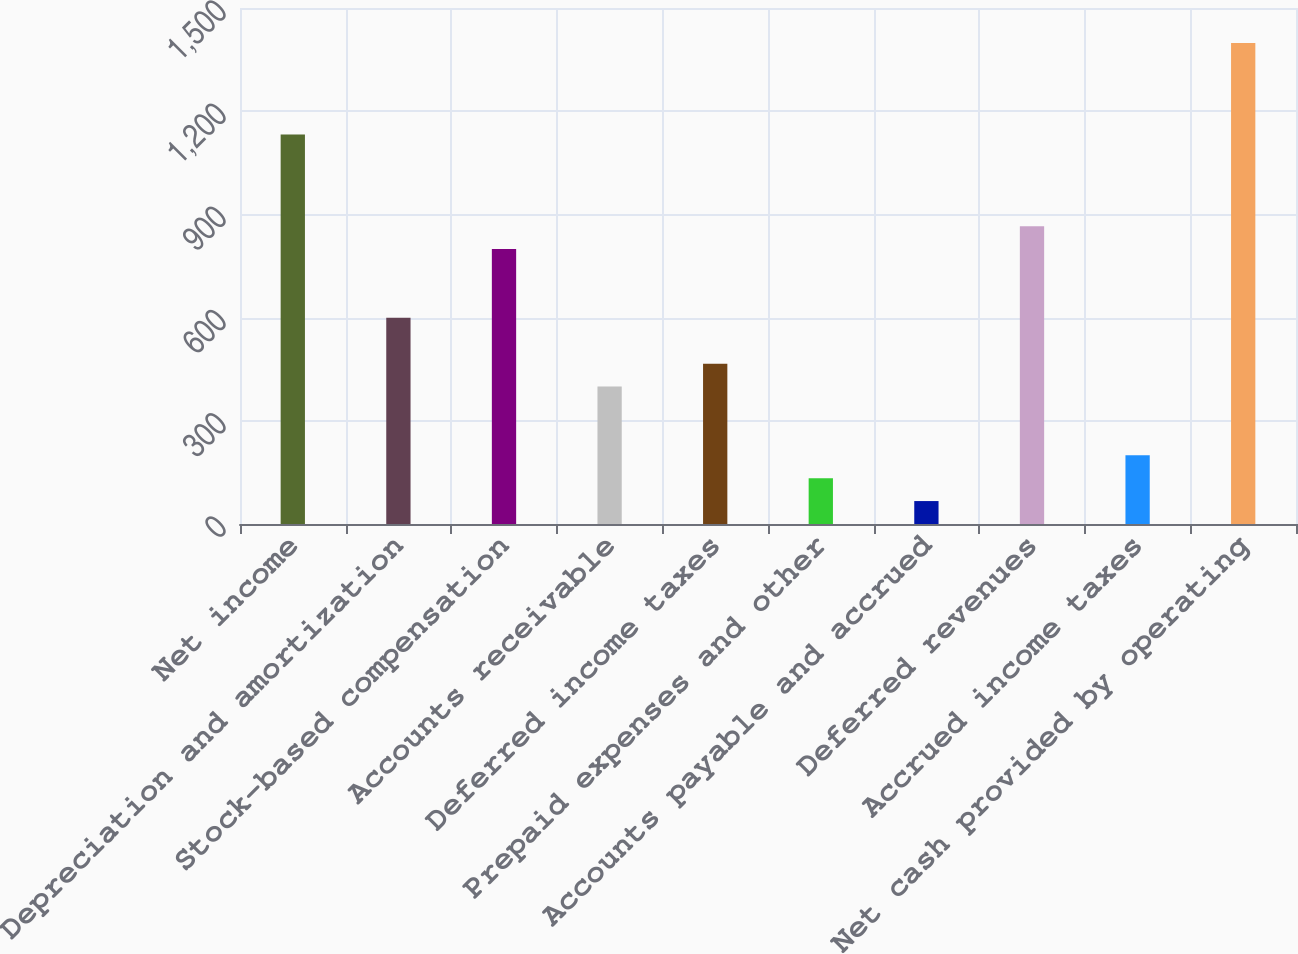Convert chart. <chart><loc_0><loc_0><loc_500><loc_500><bar_chart><fcel>Net income<fcel>Depreciation and amortization<fcel>Stock-based compensation<fcel>Accounts receivable<fcel>Deferred income taxes<fcel>Prepaid expenses and other<fcel>Accounts payable and accrued<fcel>Deferred revenues<fcel>Accrued income taxes<fcel>Net cash provided by operating<nl><fcel>1131.96<fcel>599.32<fcel>799.06<fcel>399.58<fcel>466.16<fcel>133.26<fcel>66.68<fcel>865.64<fcel>199.84<fcel>1398.28<nl></chart> 